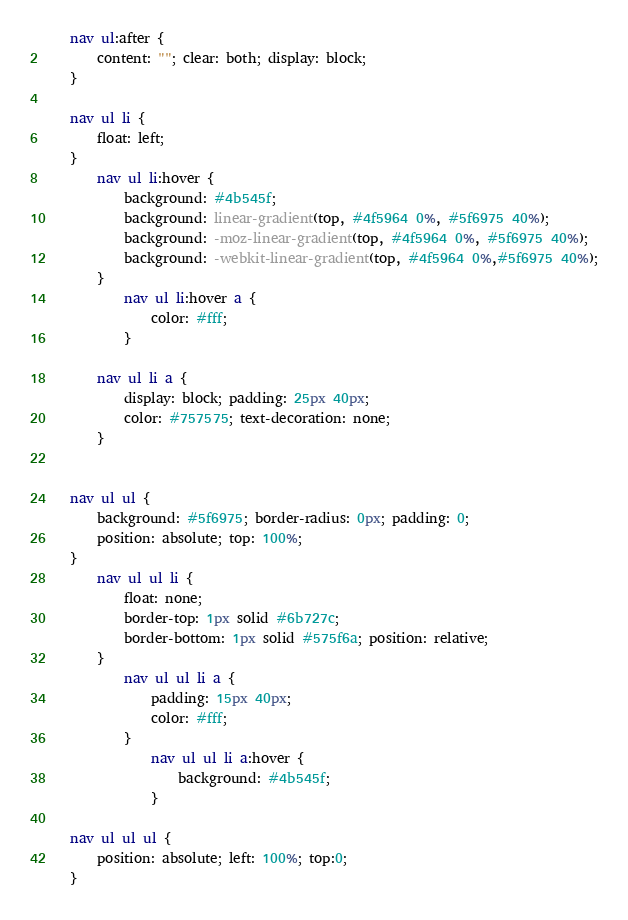<code> <loc_0><loc_0><loc_500><loc_500><_CSS_>	nav ul:after {
		content: ""; clear: both; display: block;
	}

	nav ul li {
		float: left;
	}
		nav ul li:hover {
			background: #4b545f;
			background: linear-gradient(top, #4f5964 0%, #5f6975 40%);
			background: -moz-linear-gradient(top, #4f5964 0%, #5f6975 40%);
			background: -webkit-linear-gradient(top, #4f5964 0%,#5f6975 40%);
		}
			nav ul li:hover a {
				color: #fff;
			}
		
		nav ul li a {
			display: block; padding: 25px 40px;
			color: #757575; text-decoration: none;
		}
			
		
	nav ul ul {
		background: #5f6975; border-radius: 0px; padding: 0;
		position: absolute; top: 100%;
	}
		nav ul ul li {
			float: none; 
			border-top: 1px solid #6b727c;
			border-bottom: 1px solid #575f6a; position: relative;
		}
			nav ul ul li a {
				padding: 15px 40px;
				color: #fff;
			}	
				nav ul ul li a:hover {
					background: #4b545f;
				}
		
	nav ul ul ul {
		position: absolute; left: 100%; top:0;
	}</code> 